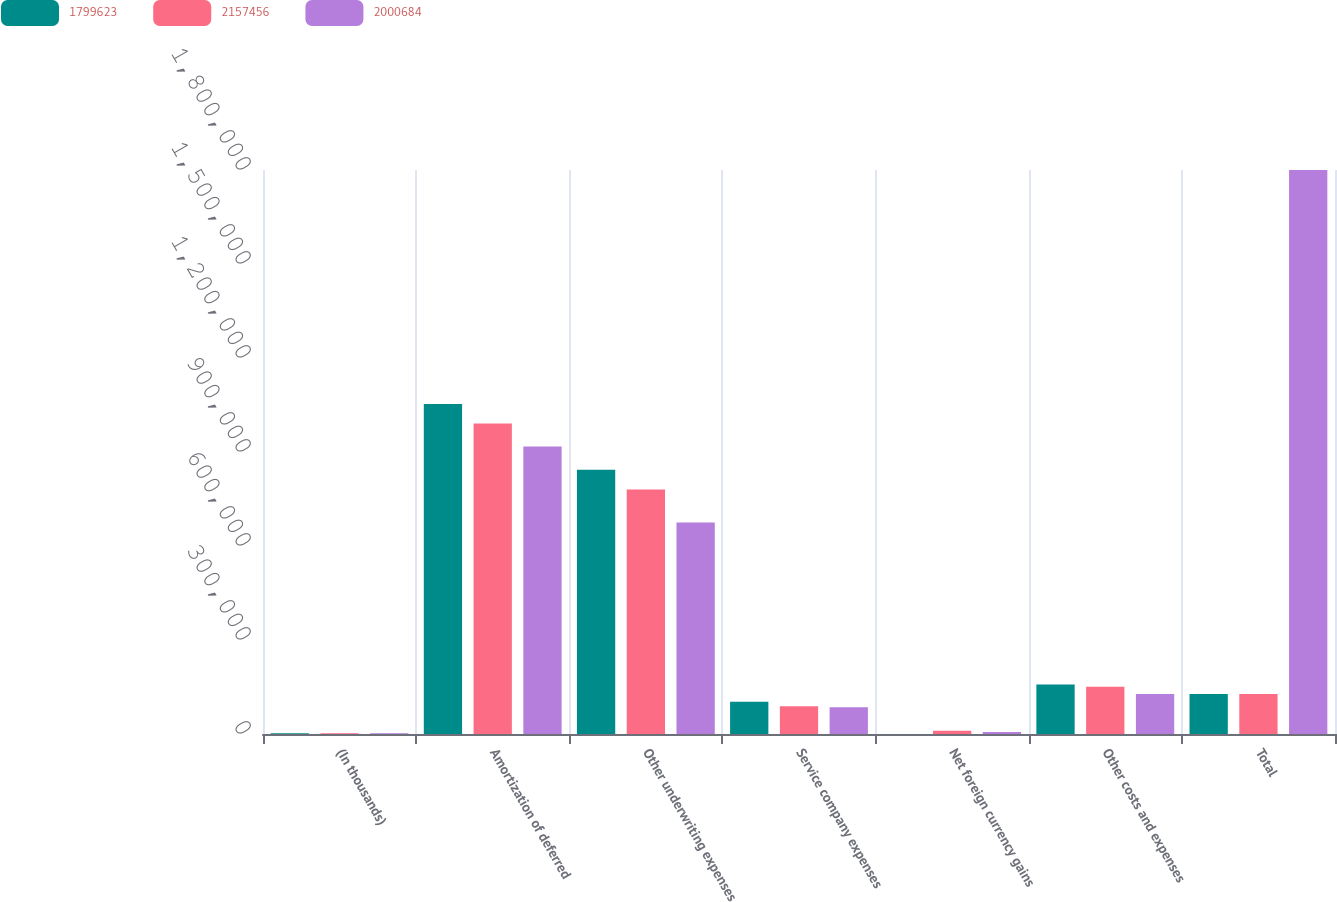Convert chart. <chart><loc_0><loc_0><loc_500><loc_500><stacked_bar_chart><ecel><fcel>(In thousands)<fcel>Amortization of deferred<fcel>Other underwriting expenses<fcel>Service company expenses<fcel>Net foreign currency gains<fcel>Other costs and expenses<fcel>Total<nl><fcel>1.79962e+06<fcel>2014<fcel>1.0534e+06<fcel>843133<fcel>102726<fcel>27<fcel>158227<fcel>127983<nl><fcel>2.15746e+06<fcel>2013<fcel>991070<fcel>780058<fcel>88662<fcel>10120<fcel>151014<fcel>127983<nl><fcel>2.00068e+06<fcel>2012<fcel>917583<fcel>675163<fcel>84986<fcel>6092<fcel>127983<fcel>1.79962e+06<nl></chart> 